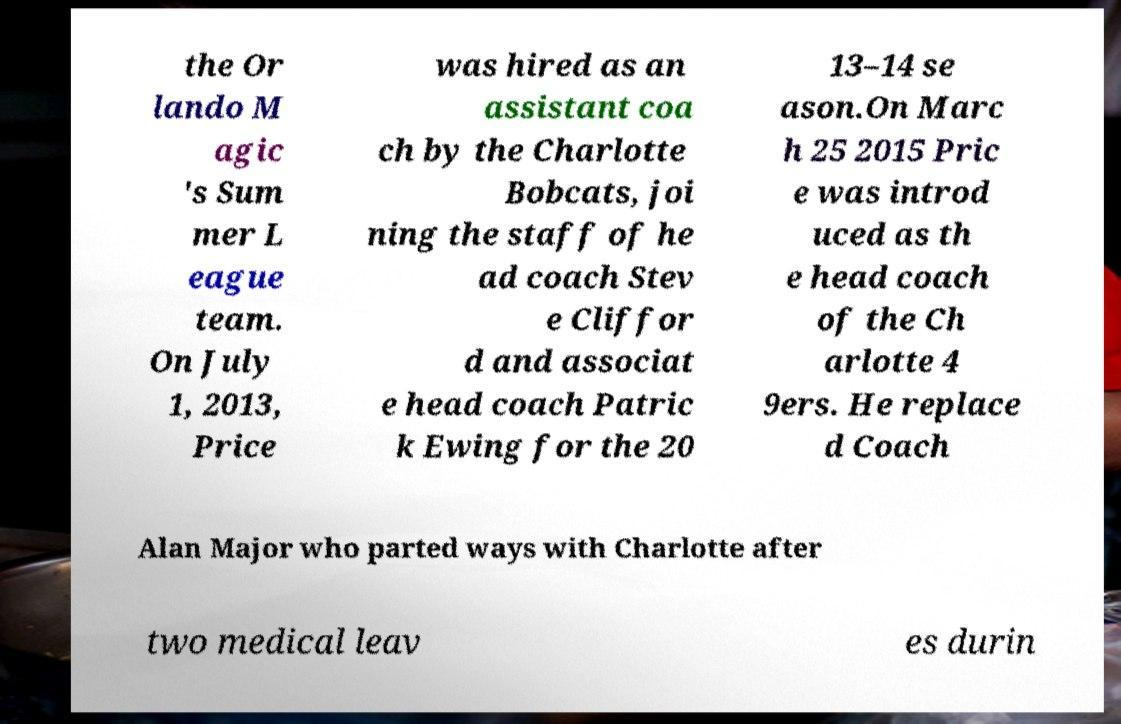Could you assist in decoding the text presented in this image and type it out clearly? the Or lando M agic 's Sum mer L eague team. On July 1, 2013, Price was hired as an assistant coa ch by the Charlotte Bobcats, joi ning the staff of he ad coach Stev e Cliffor d and associat e head coach Patric k Ewing for the 20 13–14 se ason.On Marc h 25 2015 Pric e was introd uced as th e head coach of the Ch arlotte 4 9ers. He replace d Coach Alan Major who parted ways with Charlotte after two medical leav es durin 